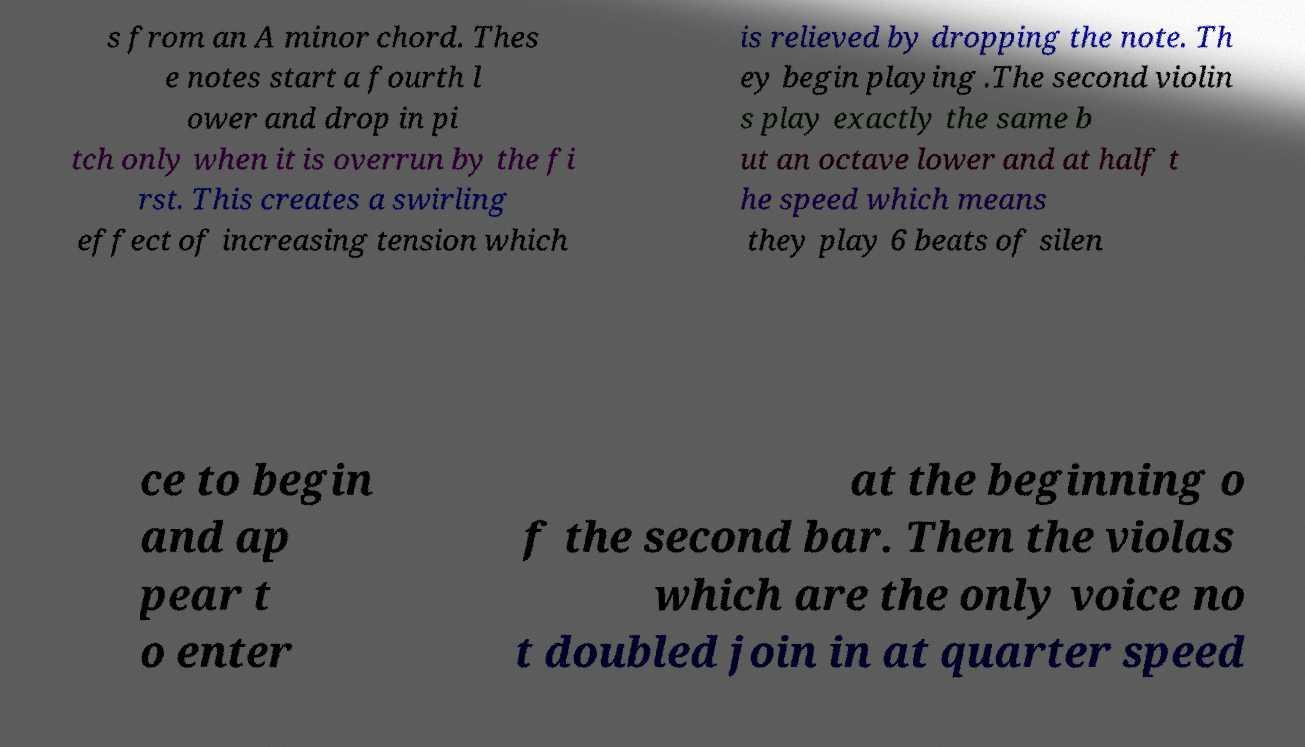I need the written content from this picture converted into text. Can you do that? s from an A minor chord. Thes e notes start a fourth l ower and drop in pi tch only when it is overrun by the fi rst. This creates a swirling effect of increasing tension which is relieved by dropping the note. Th ey begin playing .The second violin s play exactly the same b ut an octave lower and at half t he speed which means they play 6 beats of silen ce to begin and ap pear t o enter at the beginning o f the second bar. Then the violas which are the only voice no t doubled join in at quarter speed 